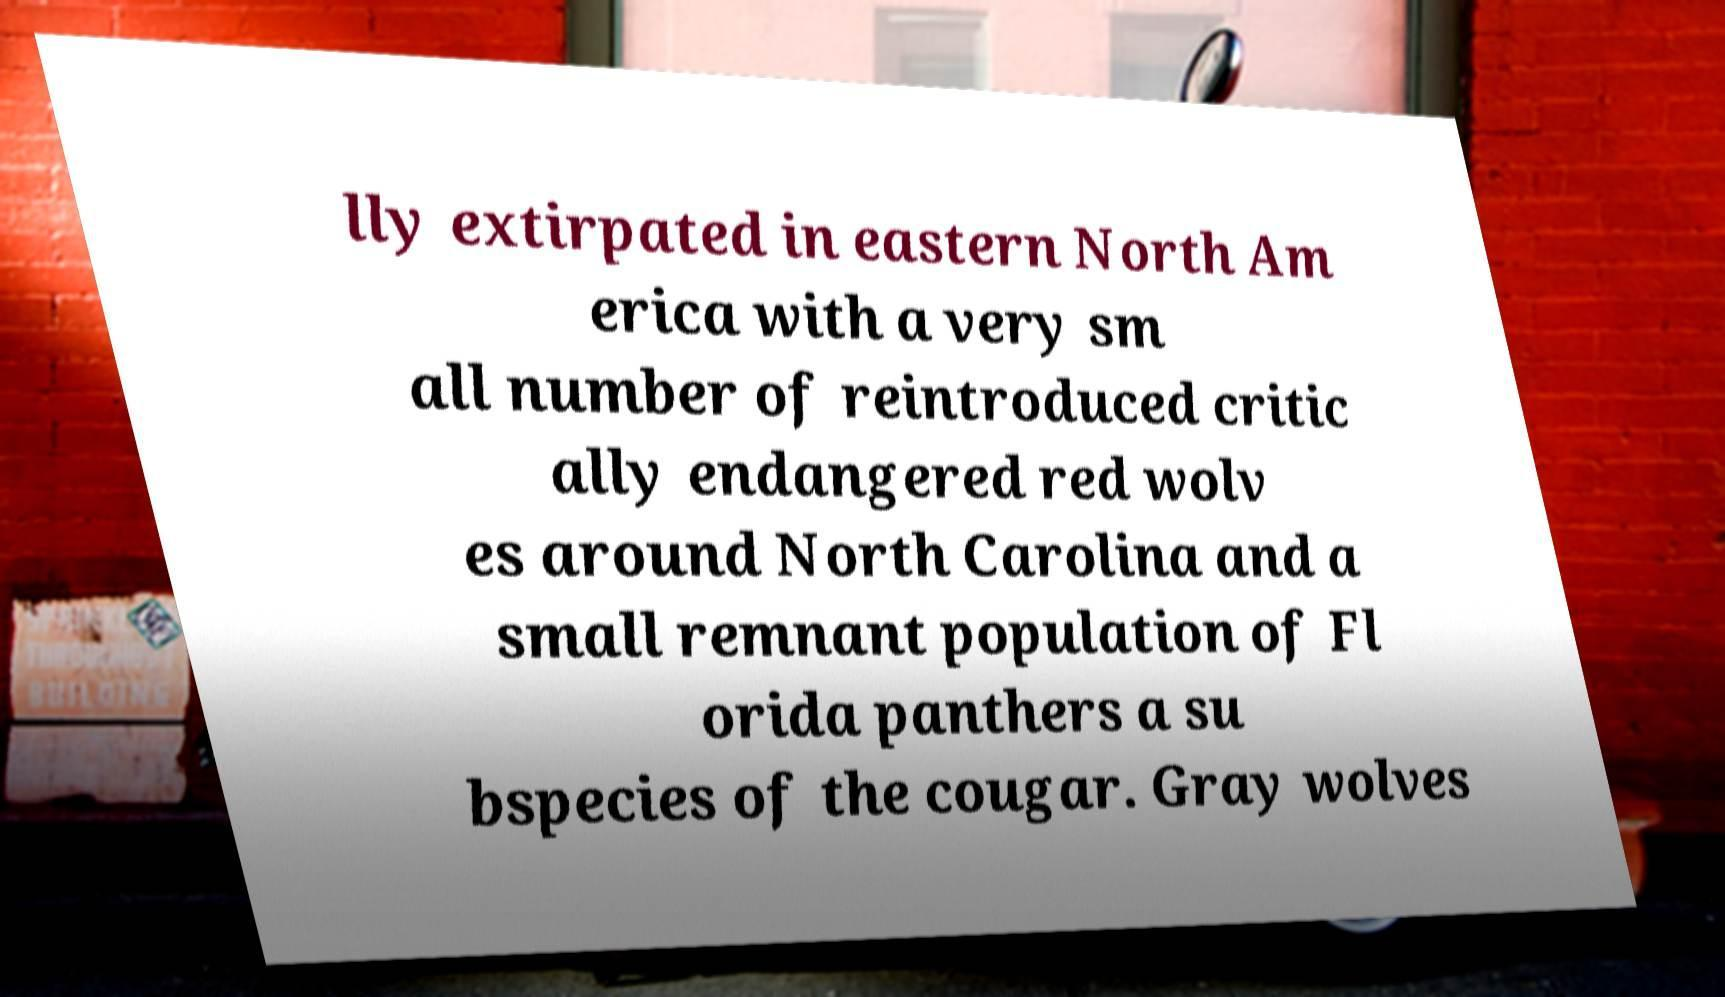Could you assist in decoding the text presented in this image and type it out clearly? lly extirpated in eastern North Am erica with a very sm all number of reintroduced critic ally endangered red wolv es around North Carolina and a small remnant population of Fl orida panthers a su bspecies of the cougar. Gray wolves 